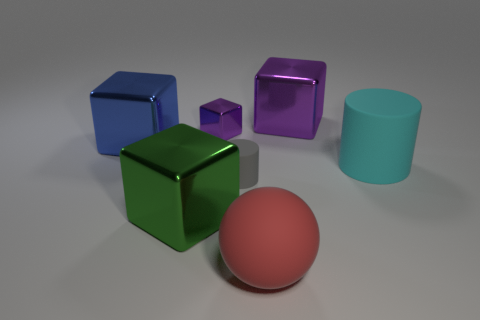Is the number of purple objects that are in front of the big purple metal thing greater than the number of purple cubes that are in front of the ball?
Offer a very short reply. Yes. The purple object that is on the right side of the small thing behind the matte cylinder that is to the left of the large cyan matte cylinder is made of what material?
Provide a short and direct response. Metal. There is a large purple thing that is made of the same material as the blue cube; what is its shape?
Offer a very short reply. Cube. There is a large cube on the left side of the large green metal object; is there a tiny object in front of it?
Your answer should be compact. Yes. How big is the red object?
Give a very brief answer. Large. How many things are either gray rubber objects or green matte blocks?
Provide a succinct answer. 1. Does the large thing that is right of the large purple metallic cube have the same material as the large thing behind the large blue thing?
Your answer should be very brief. No. There is a large cylinder that is made of the same material as the sphere; what is its color?
Keep it short and to the point. Cyan. How many shiny objects have the same size as the blue cube?
Give a very brief answer. 2. What number of other things are the same color as the ball?
Ensure brevity in your answer.  0. 